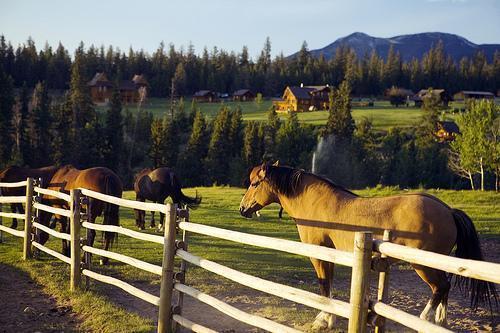How many horses are there in the picture?
Give a very brief answer. 4. 